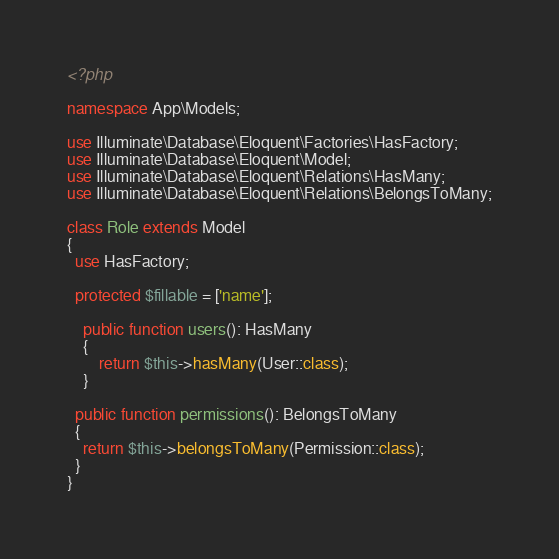Convert code to text. <code><loc_0><loc_0><loc_500><loc_500><_PHP_><?php

namespace App\Models;

use Illuminate\Database\Eloquent\Factories\HasFactory;
use Illuminate\Database\Eloquent\Model;
use Illuminate\Database\Eloquent\Relations\HasMany;
use Illuminate\Database\Eloquent\Relations\BelongsToMany;

class Role extends Model
{
  use HasFactory;
  
  protected $fillable = ['name'];

	public function users(): HasMany
	{
		return $this->hasMany(User::class);
	}

  public function permissions(): BelongsToMany
  {
  	return $this->belongsToMany(Permission::class);
  }
}
</code> 